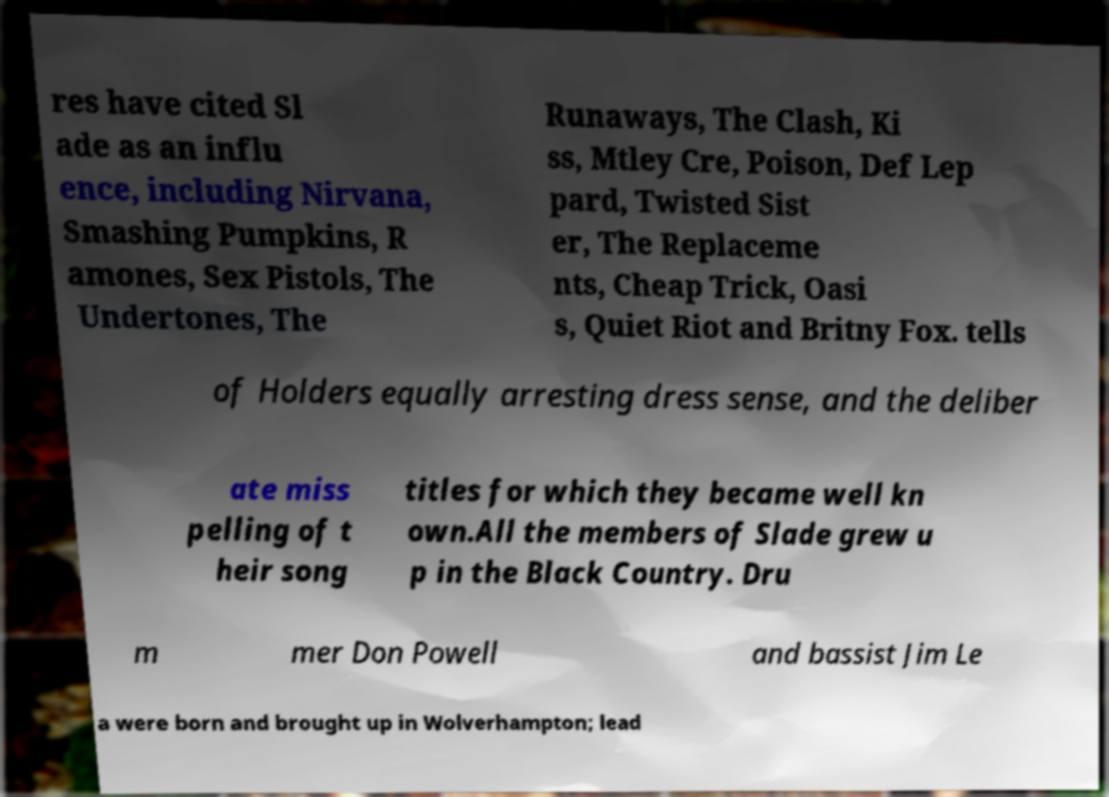Please read and relay the text visible in this image. What does it say? res have cited Sl ade as an influ ence, including Nirvana, Smashing Pumpkins, R amones, Sex Pistols, The Undertones, The Runaways, The Clash, Ki ss, Mtley Cre, Poison, Def Lep pard, Twisted Sist er, The Replaceme nts, Cheap Trick, Oasi s, Quiet Riot and Britny Fox. tells of Holders equally arresting dress sense, and the deliber ate miss pelling of t heir song titles for which they became well kn own.All the members of Slade grew u p in the Black Country. Dru m mer Don Powell and bassist Jim Le a were born and brought up in Wolverhampton; lead 